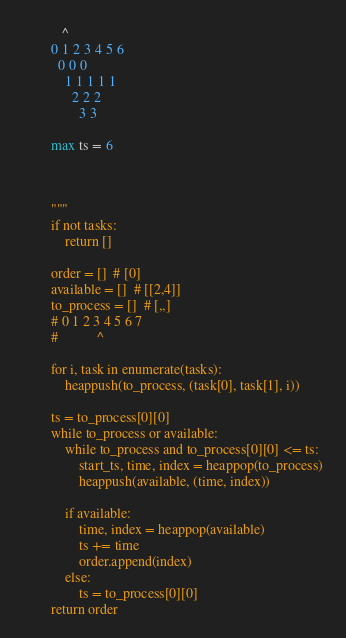<code> <loc_0><loc_0><loc_500><loc_500><_Python_>
           ^
        0 1 2 3 4 5 6
          0 0 0
            1 1 1 1 1
              2 2 2
                3 3

        max ts = 6



        """
        if not tasks:
            return []

        order = []  # [0]
        available = []  # [[2,4]]
        to_process = []  # [,,]
        # 0 1 2 3 4 5 6 7
        #           ^

        for i, task in enumerate(tasks):
            heappush(to_process, (task[0], task[1], i))

        ts = to_process[0][0]
        while to_process or available:
            while to_process and to_process[0][0] <= ts:
                start_ts, time, index = heappop(to_process)
                heappush(available, (time, index))

            if available:
                time, index = heappop(available)
                ts += time
                order.append(index)
            else:
                ts = to_process[0][0]
        return order</code> 